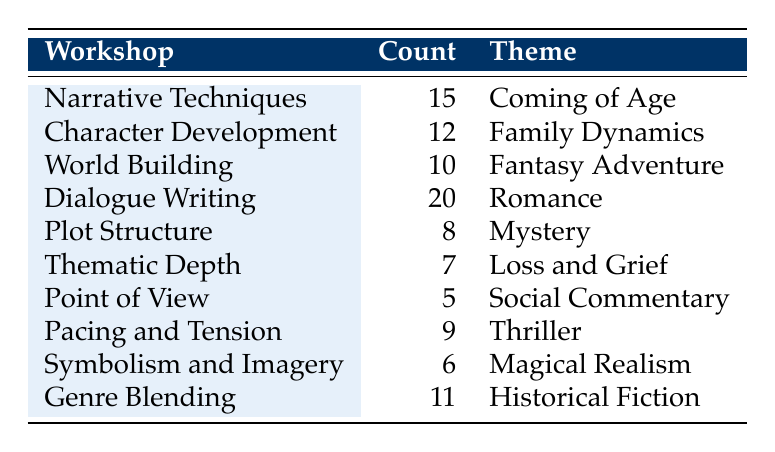What is the theme associated with the highest count in the table? The highest count in the table is 20, which is associated with the theme "Romance" under the workshop "Dialogue Writing."
Answer: Romance Which workshop corresponds to the theme "Family Dynamics"? The table shows that "Family Dynamics" corresponds to the "Character Development" workshop with a count of 12.
Answer: Character Development What is the total count of participants that explored the themes "Thriller" and "Mystery"? To find the total count, we first identify the counts for "Thriller" (9) and "Mystery" (8). Adding these together gives 9 + 8 = 17.
Answer: 17 Is there a theme related to "Loss and Grief"? Yes, the theme "Loss and Grief" is present in the table under the workshop "Thematic Depth" with a count of 7.
Answer: Yes What is the average count of participants across all workshops listed? To find the average count, we sum all counts: 15 + 12 + 10 + 20 + 8 + 7 + 5 + 9 + 6 + 11 = 99. Then, divide this sum by the number of workshops, which is 10: 99 / 10 = 9.9.
Answer: 9.9 Which workshop has the second-highest count, and what is that count? The second-highest count is 15, and it corresponds to the workshop "Narrative Techniques" with the theme "Coming of Age."
Answer: Narrative Techniques, 15 What theme has the lowest participant count, and how many participants were associated with it? The table indicates that the theme with the lowest count is "Social Commentary," with only 5 participants associated with it from the "Point of View" workshop.
Answer: Social Commentary, 5 Are there more themes related to fantasy than those related to historical fiction? No, there is one theme related to fantasy titled "Fantasy Adventure" and one for historical fiction, which is "Historical Fiction." Thus, the counts are equal.
Answer: No 